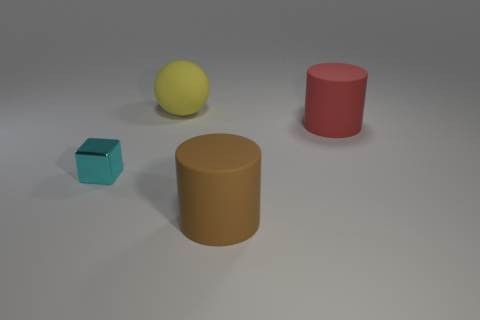There is a red thing that is the same shape as the large brown thing; what is it made of?
Make the answer very short. Rubber. Are there any other things that have the same material as the cube?
Your answer should be very brief. No. What is the material of the tiny cube?
Give a very brief answer. Metal. Are the large yellow ball and the brown cylinder made of the same material?
Provide a short and direct response. Yes. How many rubber things are either red cylinders or brown balls?
Keep it short and to the point. 1. There is a object left of the big matte sphere; what shape is it?
Your answer should be compact. Cube. There is a big thing that is on the left side of the big red cylinder and in front of the sphere; what shape is it?
Your answer should be compact. Cylinder. There is a big matte object that is to the right of the brown rubber object; is it the same shape as the large thing that is in front of the red cylinder?
Provide a short and direct response. Yes. What size is the thing that is to the left of the big ball?
Your answer should be compact. Small. What size is the cyan block in front of the big cylinder behind the small cyan block?
Provide a succinct answer. Small. 